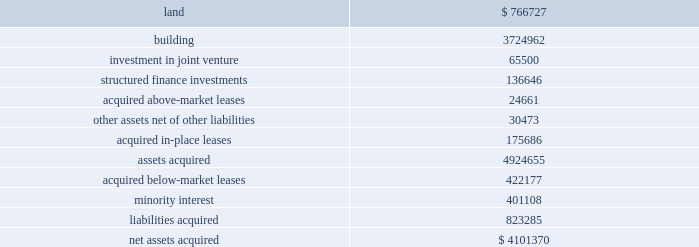Notes to consolidated financial statements in march 2008 , the fasb issued guidance which requires entities to provide greater transparency about ( a ) how and why an entity uses derivative instruments , ( b ) how derivative instruments and related hedged items are accounted , and ( c ) how derivative instruments and related hedged items affect an entity 2019s financial position , results of operations , and cash flows .
This guidance was effective on january 1 , 2009 .
The adoption of this guidance did not have a material impact on our consolidated financial statements .
In june 2009 , the fasb issued guidance on accounting for transfers of financial assets .
This guidance amends various components of the existing guidance governing sale accounting , including the recog- nition of assets obtained and liabilities assumed as a result of a transfer , and considerations of effective control by a transferor over transferred assets .
In addition , this guidance removes the exemption for qualifying special purpose entities from the consolidation guidance .
This guidance is effective january 1 , 2010 , with early adoption prohibited .
While the amended guidance governing sale accounting is applied on a prospec- tive basis , the removal of the qualifying special purpose entity exception will require us to evaluate certain entities for consolidation .
While we are evaluating the effect of adoption of this guidance , we currently believe that its adoption will not have a material impact on our consolidated financial statement .
In june 2009 , the fasb amended the guidance for determin- ing whether an entity is a variable interest entity , or vie , and requires the performance of a qualitative rather than a quantitative analysis to determine the primary beneficiary of a vie .
Under this guidance , an entity would be required to consolidate a vie if it has ( i ) the power to direct the activities that most significantly impact the entity 2019s economic performance and ( ii ) the obligation to absorb losses of the vie or the right to receive benefits from the vie that could be significant to the vie .
This guidance is effective for the first annual reporting period that begins after november 15 , 2009 , with early adoption prohibited .
While we are currently evaluating the effect of adoption of this guidance , we currently believe that its adoption will not have a material impact on our consoli- dated financial statements .
Note 3 / property acquisitions 2009 acquisitions during 2009 , we acquired the sub-leasehold positions at 420 lexington avenue for an aggregate purchase price of approximately $ 15.9 million .
2008 acquisitions in february 2008 , we , through our joint venture with jeff sutton , acquired the properties located at 182 broadway and 63 nassau street for approximately $ 30.0 million in the aggregate .
These properties are located adjacent to 180 broadway which we acquired in august 2007 .
As part of the acquisition we also closed on a $ 31.0 million loan which bears interest at 225 basis points over the 30-day libor .
The loan has a three-year term and two one-year extensions .
We drew down $ 21.1 mil- lion at the closing to pay the balance of the acquisition costs .
During the second quarter of 2008 , we , through a joint ven- ture with nysters , acquired various interests in the fee positions at 919 third avenue for approximately $ 32.8 million .
As a result , our joint venture controls the entire fee position .
2007 acquisitions in january 2007 , we acquired reckson for approximately $ 6.0 billion , inclusive of transaction costs .
Simultaneously , we sold approximately $ 2.0 billion of the reckson assets to an asset purchasing venture led by certain of reckson 2019s former executive management .
The transaction included the acquisition of 30 properties encompassing approximately 9.2 million square feet , of which five properties encompassing approxi- mately 4.2 million square feet are located in manhattan .
The following summarizes our allocation of the purchase price to the assets and liabilities acquired from reckson ( in thousands ) : .

What is the available capacity of the 31.0 million acquisition loan as of august 2007 , in millions? 
Computations: (31.0 - 21.1)
Answer: 9.9. 